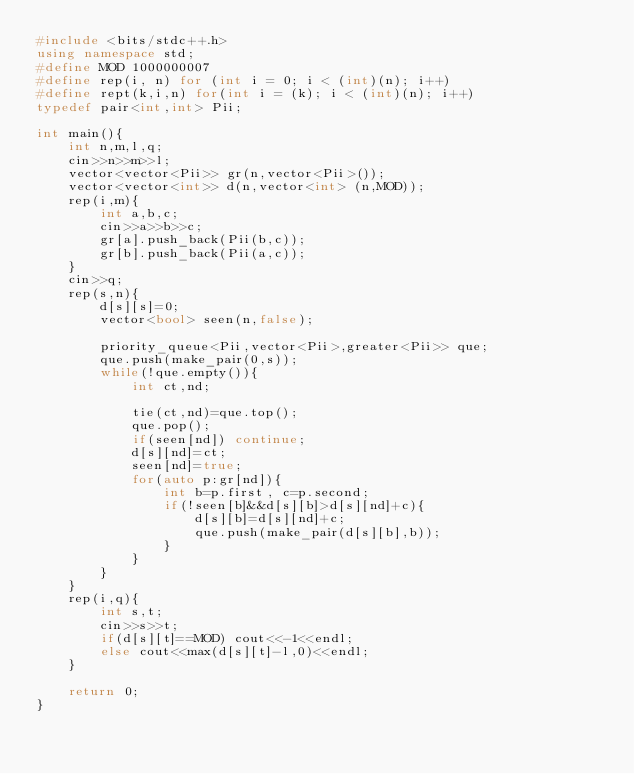<code> <loc_0><loc_0><loc_500><loc_500><_C++_>#include <bits/stdc++.h>
using namespace std;
#define MOD 1000000007
#define rep(i, n) for (int i = 0; i < (int)(n); i++)
#define rept(k,i,n) for(int i = (k); i < (int)(n); i++)
typedef pair<int,int> Pii;

int main(){
    int n,m,l,q;
    cin>>n>>m>>l;
    vector<vector<Pii>> gr(n,vector<Pii>());
    vector<vector<int>> d(n,vector<int> (n,MOD));
    rep(i,m){
        int a,b,c;
        cin>>a>>b>>c;
        gr[a].push_back(Pii(b,c));
        gr[b].push_back(Pii(a,c));
    }
    cin>>q;
    rep(s,n){
        d[s][s]=0;
        vector<bool> seen(n,false);
        
        priority_queue<Pii,vector<Pii>,greater<Pii>> que;
        que.push(make_pair(0,s));
        while(!que.empty()){
            int ct,nd;

            tie(ct,nd)=que.top();
            que.pop();
            if(seen[nd]) continue;
            d[s][nd]=ct;
            seen[nd]=true;
            for(auto p:gr[nd]){
                int b=p.first, c=p.second;
                if(!seen[b]&&d[s][b]>d[s][nd]+c){
                    d[s][b]=d[s][nd]+c;
                    que.push(make_pair(d[s][b],b));
                }
            }
        }
    }
    rep(i,q){
        int s,t;
        cin>>s>>t;
        if(d[s][t]==MOD) cout<<-1<<endl;
        else cout<<max(d[s][t]-l,0)<<endl;
    }

    return 0;
}</code> 